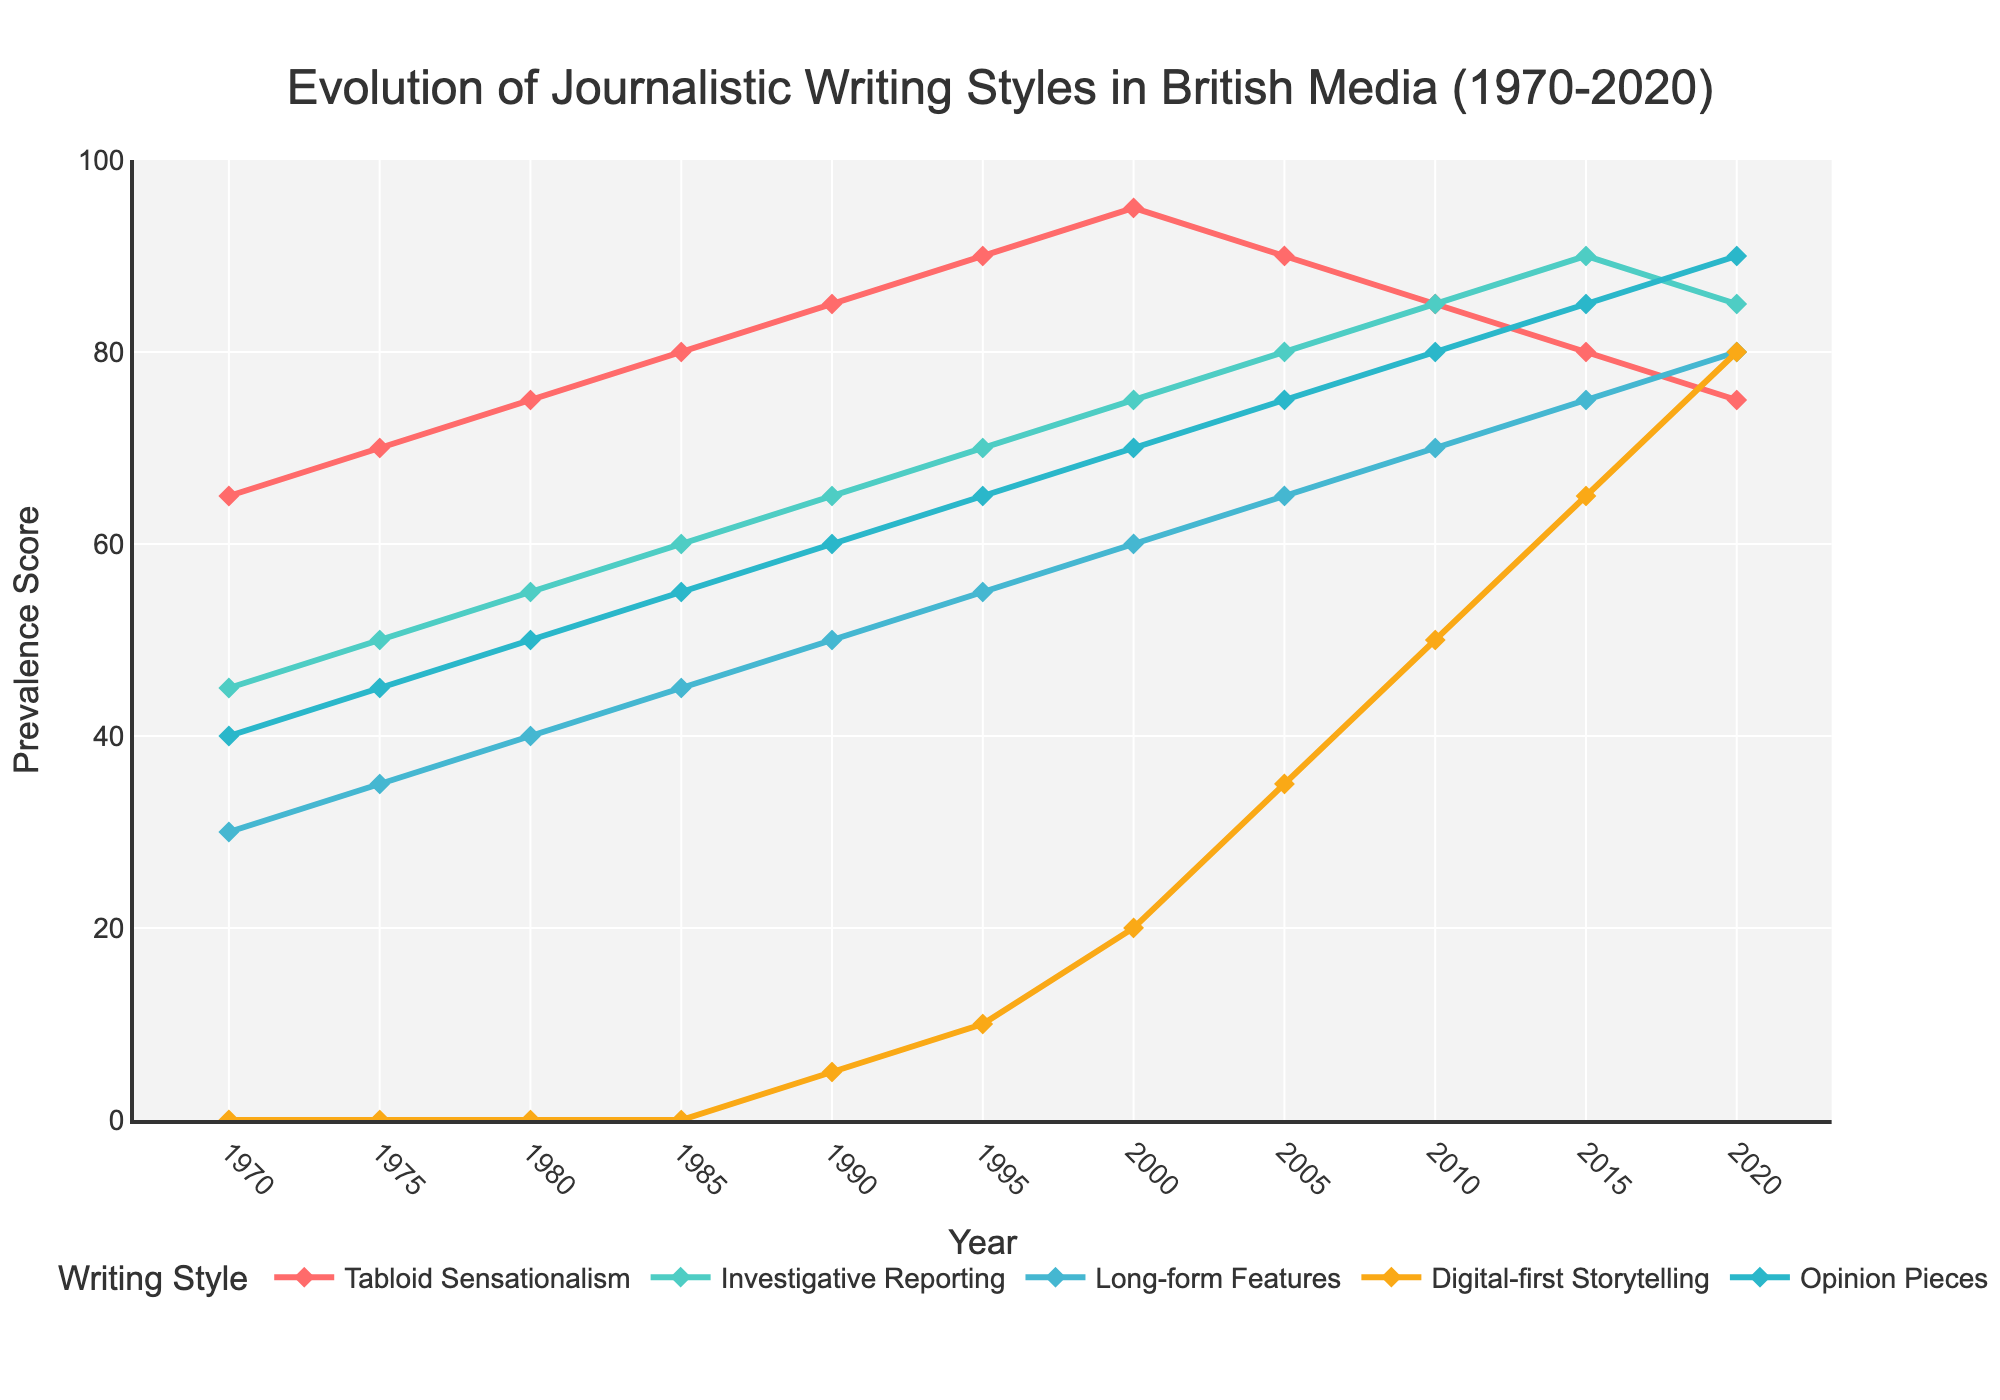What writing style had the highest prevalence in 1985? To determine the highest prevalence in 1985, look for the highest y-value in this year on the chart. Tabloid Sensationalism (80) is clearly the highest.
Answer: Tabloid Sensationalism How did the prevalence of Digital-first Storytelling change between 2000 and 2020? Compare the y-values of Digital-first Storytelling in 2000 (20) and 2020 (80). The difference is 80 - 20 = 60, showing an increase.
Answer: Increased by 60 Which two writing styles converged in prevalence around 2010? In 2010, look for lines that appear close to one another. Investigative Reporting and Long-form Features both have values of 85 and 70, but they are not close. Instead, it is Digital-first Storytelling and Long-form Features that approached each other at 50 and 70 respectively.
Answer: Digital-first Storytelling and Long-form Features Between 1970 and 2020, which writing style saw the most consistent growth without a decline? Review the trend lines to see if any style keeps going up without decreasing at any point. Investigative Reporting shows consistent growth every year.
Answer: Investigative Reporting What was the difference in prevalence between Long-form Features and Opinion Pieces in 2015? Look at the y-values for Long-form Features and Opinion Pieces in 2015, which are 75 and 85 respectively. The difference is 85 - 75 = 10.
Answer: 10 Which writing style saw a decline after peaking in 2000? Ascertain the style that had its highest y-value in 2000 and then decreased. Tabloid Sensationalism peaks at 95 in 2000 and declines afterward.
Answer: Tabloid Sensationalism How many writing styles had a prevalence score of 70 or greater in 2005? Inspect the y-values for all writing styles in 2005 to count the number of values that are 70 or above. There are Investigative Reporting (80), Long-form Features (65, not counted), Digital-first Storytelling (35, not counted), Tabloid Sensationalism (90), and Opinion Pieces (75). Thus, 3 styles qualify.
Answer: 3 What was the combined prevalence score for all writing styles in 1980? Sum up all the y-values for 1980: Tabloid Sensationalism (75) + Investigative Reporting (55) + Long-form Features (40) + Digital-first Storytelling (0) + Opinion Pieces (50) = 220.
Answer: 220 